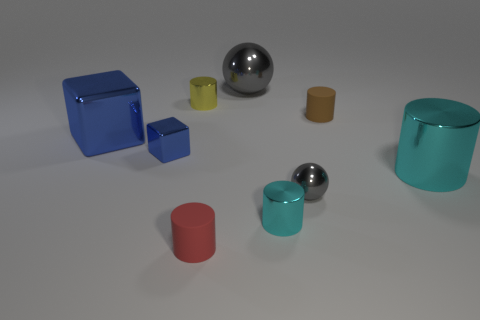There is a yellow metallic cylinder; is it the same size as the matte cylinder behind the tiny red matte cylinder?
Your response must be concise. Yes. The brown object has what size?
Your response must be concise. Small. There is a sphere that is the same material as the small gray thing; what color is it?
Your response must be concise. Gray. What number of gray spheres have the same material as the brown object?
Make the answer very short. 0. What number of things are either big cyan metallic things or cyan metal cylinders in front of the tiny gray shiny ball?
Your answer should be very brief. 2. Is the material of the ball in front of the brown cylinder the same as the small brown object?
Your response must be concise. No. The cube that is the same size as the yellow metallic cylinder is what color?
Offer a terse response. Blue. Are there any large cyan objects of the same shape as the yellow shiny thing?
Give a very brief answer. Yes. What color is the large thing on the left side of the shiny sphere that is behind the shiny cylinder left of the small red rubber cylinder?
Your answer should be very brief. Blue. What number of shiny objects are tiny blocks or cyan objects?
Offer a terse response. 3. 